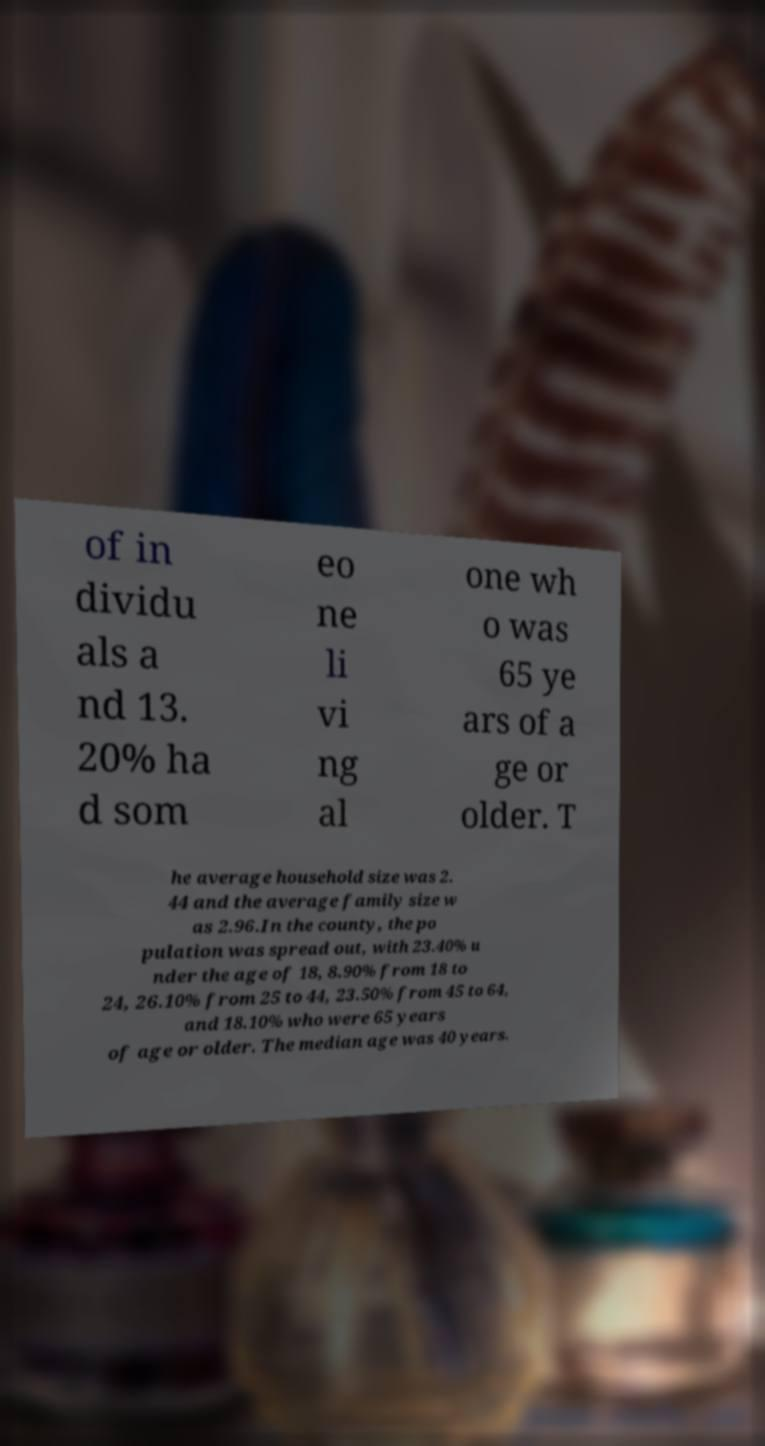Could you assist in decoding the text presented in this image and type it out clearly? of in dividu als a nd 13. 20% ha d som eo ne li vi ng al one wh o was 65 ye ars of a ge or older. T he average household size was 2. 44 and the average family size w as 2.96.In the county, the po pulation was spread out, with 23.40% u nder the age of 18, 8.90% from 18 to 24, 26.10% from 25 to 44, 23.50% from 45 to 64, and 18.10% who were 65 years of age or older. The median age was 40 years. 